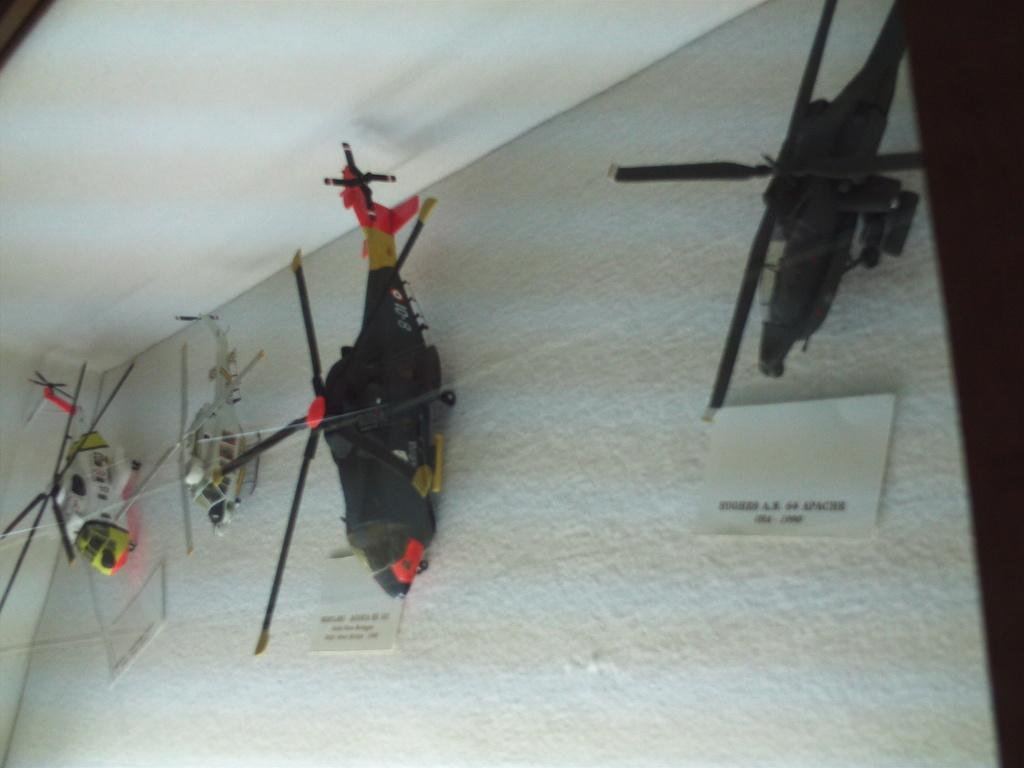What objects are present in the image? There are four toy helicopters in the image. What is the color of the surface on which the toy helicopters are placed? The toy helicopters are on a white surface. What can be seen in the background of the image? There is a wall in the background of the image. What type of joke is being told by the toy helicopters in the image? There is no indication in the image that the toy helicopters are telling a joke, as they are inanimate objects. 